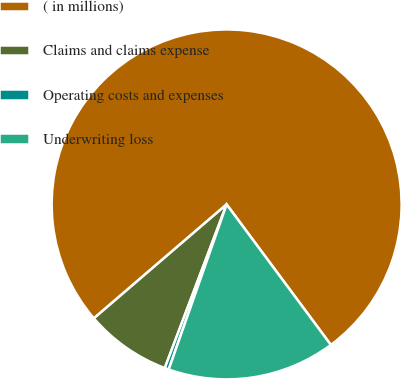Convert chart. <chart><loc_0><loc_0><loc_500><loc_500><pie_chart><fcel>( in millions)<fcel>Claims and claims expense<fcel>Operating costs and expenses<fcel>Underwriting loss<nl><fcel>76.13%<fcel>7.96%<fcel>0.38%<fcel>15.53%<nl></chart> 